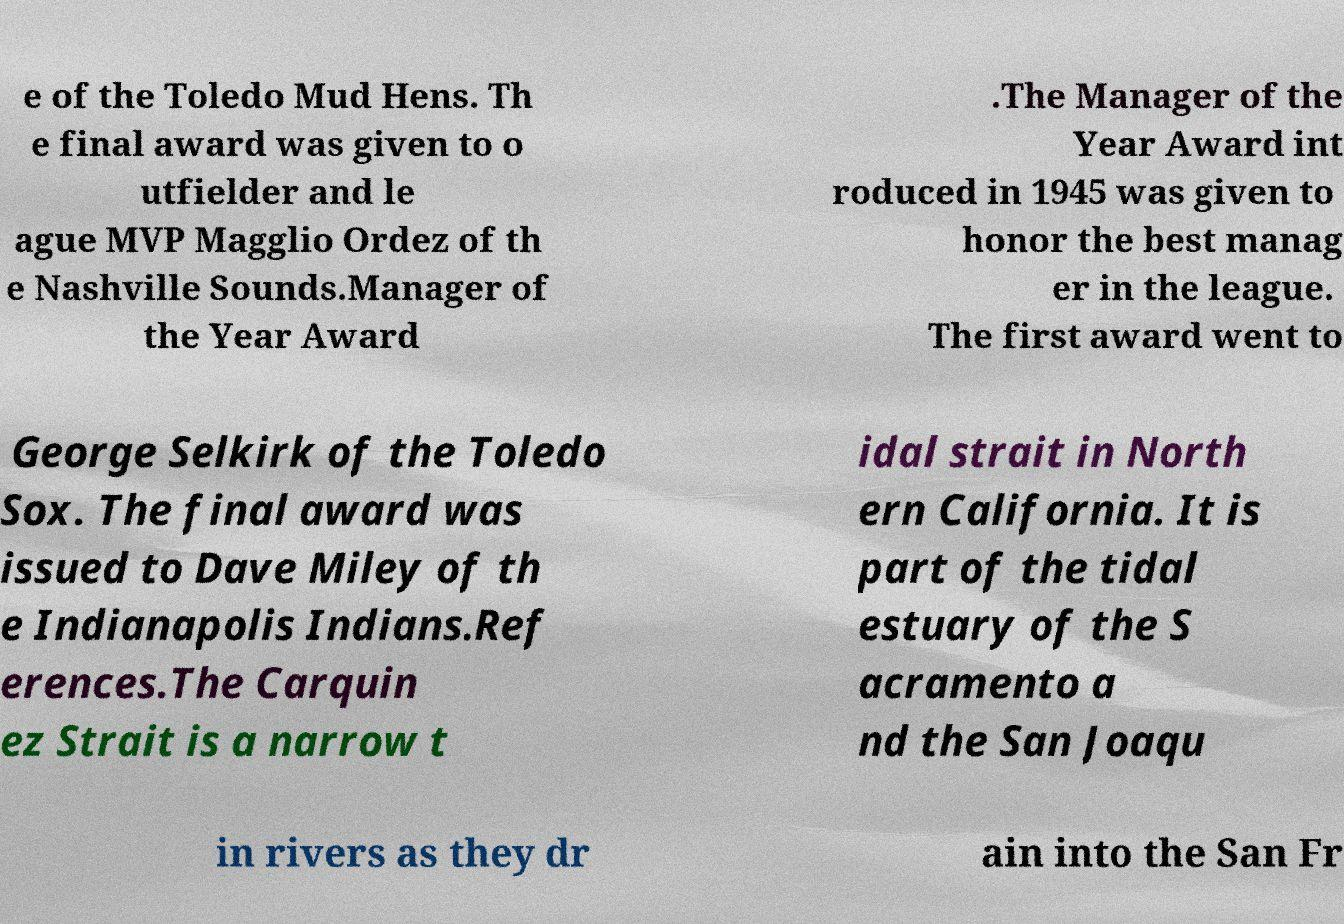Could you extract and type out the text from this image? e of the Toledo Mud Hens. Th e final award was given to o utfielder and le ague MVP Magglio Ordez of th e Nashville Sounds.Manager of the Year Award .The Manager of the Year Award int roduced in 1945 was given to honor the best manag er in the league. The first award went to George Selkirk of the Toledo Sox. The final award was issued to Dave Miley of th e Indianapolis Indians.Ref erences.The Carquin ez Strait is a narrow t idal strait in North ern California. It is part of the tidal estuary of the S acramento a nd the San Joaqu in rivers as they dr ain into the San Fr 